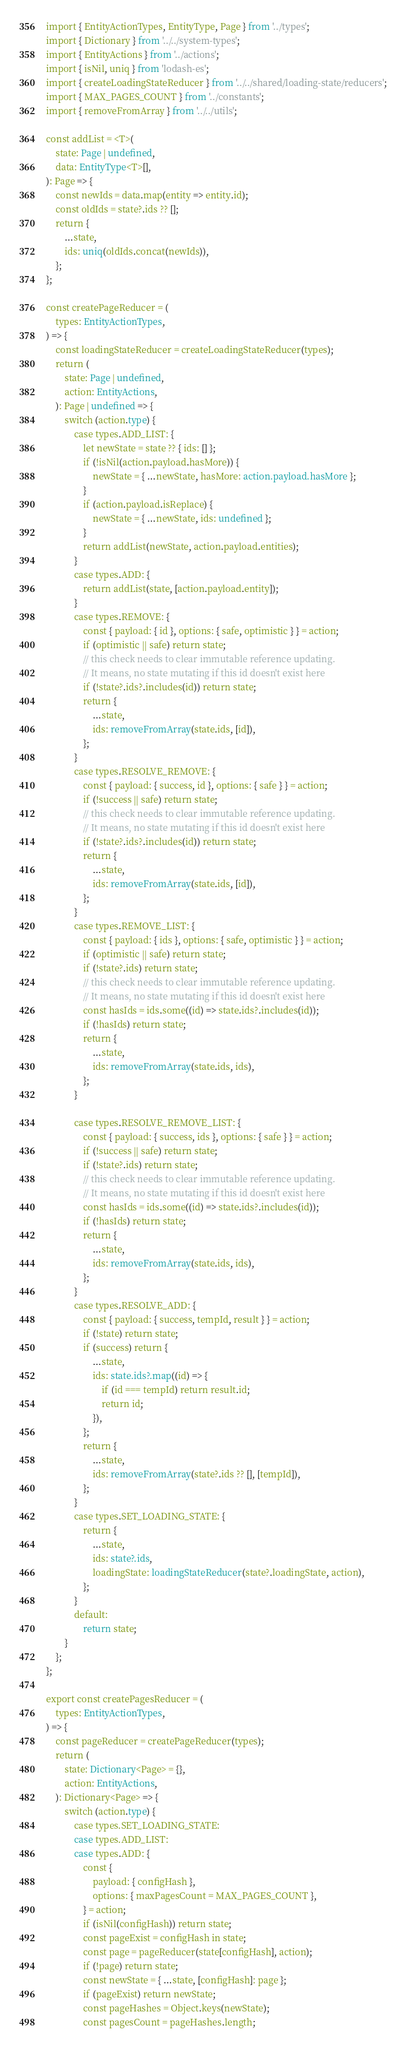Convert code to text. <code><loc_0><loc_0><loc_500><loc_500><_TypeScript_>import { EntityActionTypes, EntityType, Page } from '../types';
import { Dictionary } from '../../system-types';
import { EntityActions } from '../actions';
import { isNil, uniq } from 'lodash-es';
import { createLoadingStateReducer } from '../../shared/loading-state/reducers';
import { MAX_PAGES_COUNT } from '../constants';
import { removeFromArray } from '../../utils';

const addList = <T>(
    state: Page | undefined,
    data: EntityType<T>[],
): Page => {
    const newIds = data.map(entity => entity.id);
    const oldIds = state?.ids ?? [];
    return {
        ...state,
        ids: uniq(oldIds.concat(newIds)),
    };
};

const createPageReducer = (
    types: EntityActionTypes,
) => {
    const loadingStateReducer = createLoadingStateReducer(types);
    return (
        state: Page | undefined,
        action: EntityActions,
    ): Page | undefined => {
        switch (action.type) {
            case types.ADD_LIST: {
                let newState = state ?? { ids: [] };
                if (!isNil(action.payload.hasMore)) {
                    newState = { ...newState, hasMore: action.payload.hasMore };
                }
                if (action.payload.isReplace) {
                    newState = { ...newState, ids: undefined };
                }
                return addList(newState, action.payload.entities);
            }
            case types.ADD: {
                return addList(state, [action.payload.entity]);
            }
            case types.REMOVE: {
                const { payload: { id }, options: { safe, optimistic } } = action;
                if (optimistic || safe) return state;
                // this check needs to clear immutable reference updating.
                // It means, no state mutating if this id doesn't exist here
                if (!state?.ids?.includes(id)) return state;
                return {
                    ...state,
                    ids: removeFromArray(state.ids, [id]),
                };
            }
            case types.RESOLVE_REMOVE: {
                const { payload: { success, id }, options: { safe } } = action;
                if (!success || safe) return state;
                // this check needs to clear immutable reference updating.
                // It means, no state mutating if this id doesn't exist here
                if (!state?.ids?.includes(id)) return state;
                return {
                    ...state,
                    ids: removeFromArray(state.ids, [id]),
                };
            }
            case types.REMOVE_LIST: {
                const { payload: { ids }, options: { safe, optimistic } } = action;
                if (optimistic || safe) return state;
                if (!state?.ids) return state;
                // this check needs to clear immutable reference updating.
                // It means, no state mutating if this id doesn't exist here
                const hasIds = ids.some((id) => state.ids?.includes(id));
                if (!hasIds) return state;
                return {
                    ...state,
                    ids: removeFromArray(state.ids, ids),
                };
            }

            case types.RESOLVE_REMOVE_LIST: {
                const { payload: { success, ids }, options: { safe } } = action;
                if (!success || safe) return state;
                if (!state?.ids) return state;
                // this check needs to clear immutable reference updating.
                // It means, no state mutating if this id doesn't exist here
                const hasIds = ids.some((id) => state.ids?.includes(id));
                if (!hasIds) return state;
                return {
                    ...state,
                    ids: removeFromArray(state.ids, ids),
                };
            }
            case types.RESOLVE_ADD: {
                const { payload: { success, tempId, result } } = action;
                if (!state) return state;
                if (success) return {
                    ...state,
                    ids: state.ids?.map((id) => {
                        if (id === tempId) return result.id;
                        return id;
                    }),
                };
                return {
                    ...state,
                    ids: removeFromArray(state?.ids ?? [], [tempId]),
                };
            }
            case types.SET_LOADING_STATE: {
                return {
                    ...state,
                    ids: state?.ids,
                    loadingState: loadingStateReducer(state?.loadingState, action),
                };
            }
            default:
                return state;
        }
    };
};

export const createPagesReducer = (
    types: EntityActionTypes,
) => {
    const pageReducer = createPageReducer(types);
    return (
        state: Dictionary<Page> = {},
        action: EntityActions,
    ): Dictionary<Page> => {
        switch (action.type) {
            case types.SET_LOADING_STATE:
            case types.ADD_LIST:
            case types.ADD: {
                const {
                    payload: { configHash },
                    options: { maxPagesCount = MAX_PAGES_COUNT },
                } = action;
                if (isNil(configHash)) return state;
                const pageExist = configHash in state;
                const page = pageReducer(state[configHash], action);
                if (!page) return state;
                const newState = { ...state, [configHash]: page };
                if (pageExist) return newState;
                const pageHashes = Object.keys(newState);
                const pagesCount = pageHashes.length;</code> 